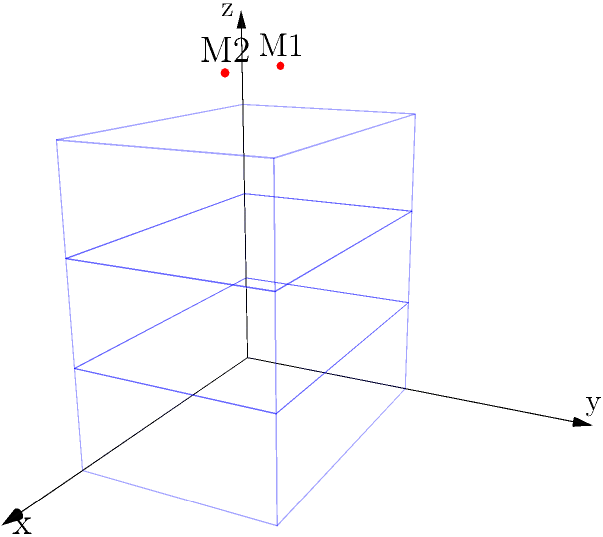In a 3D coordinate system, the choir risers are represented by three levels: the bottom level spans from $z=0$ to $z=1$, the middle level from $z=1$ to $z=2$, and the top level from $z=2$ to $z=3$. Each level has a width of 3 units along the x-axis and a depth of 2 units along the y-axis. Two microphones, M1 and M2, are positioned at $(1,1,3.5)$ and $(2,1,3.5)$ respectively. Calculate the distance between the two microphones. To calculate the distance between the two microphones, we can use the 3D distance formula:

$$d = \sqrt{(x_2-x_1)^2 + (y_2-y_1)^2 + (z_2-z_1)^2}$$

Where $(x_1,y_1,z_1)$ are the coordinates of M1 and $(x_2,y_2,z_2)$ are the coordinates of M2.

Step 1: Identify the coordinates
M1: $(1,1,3.5)$
M2: $(2,1,3.5)$

Step 2: Calculate the differences
$x_2-x_1 = 2-1 = 1$
$y_2-y_1 = 1-1 = 0$
$z_2-z_1 = 3.5-3.5 = 0$

Step 3: Square the differences
$(x_2-x_1)^2 = 1^2 = 1$
$(y_2-y_1)^2 = 0^2 = 0$
$(z_2-z_1)^2 = 0^2 = 0$

Step 4: Sum the squared differences
$1 + 0 + 0 = 1$

Step 5: Take the square root of the sum
$d = \sqrt{1} = 1$

Therefore, the distance between the two microphones is 1 unit.
Answer: 1 unit 